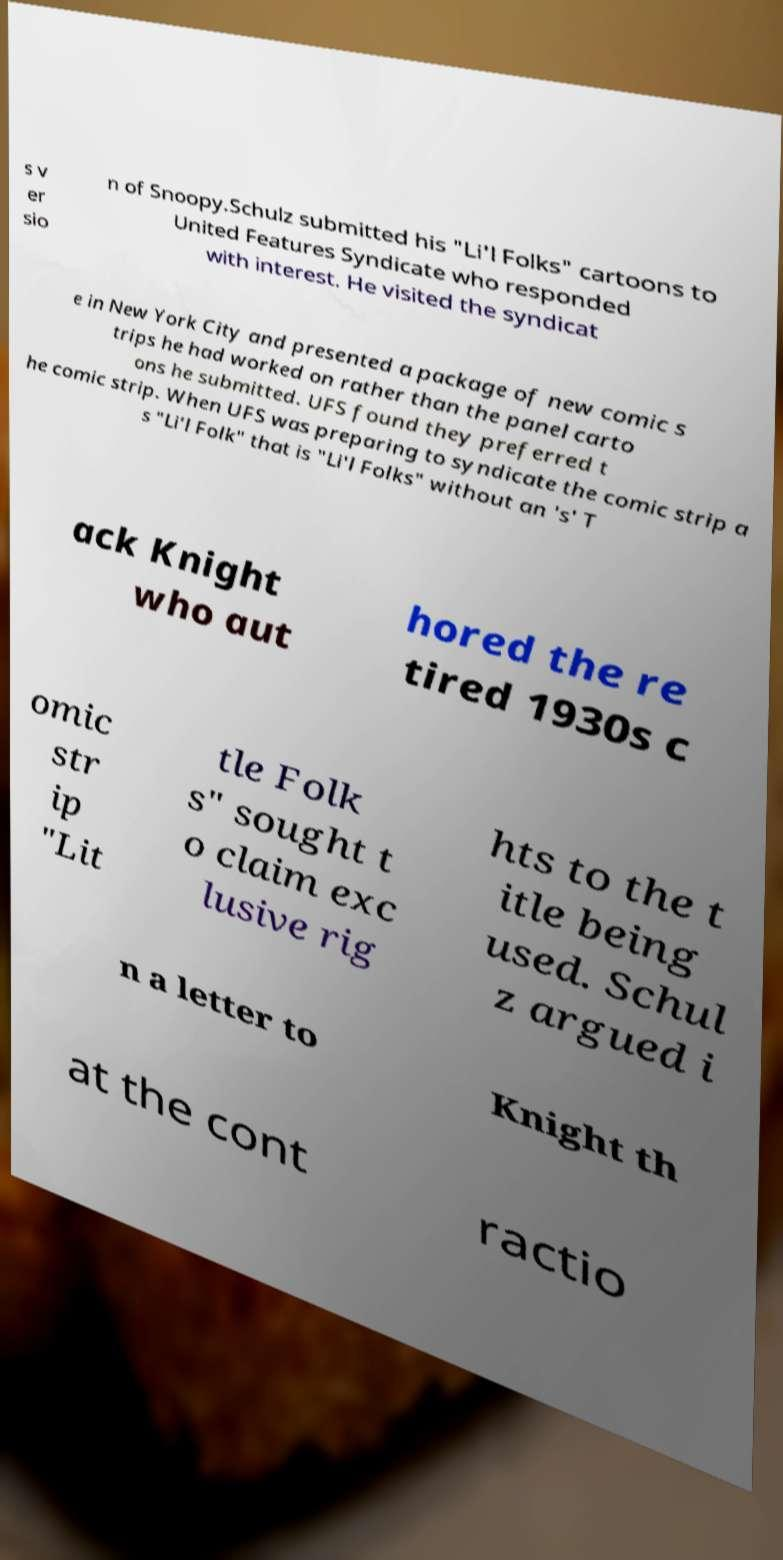For documentation purposes, I need the text within this image transcribed. Could you provide that? s v er sio n of Snoopy.Schulz submitted his "Li'l Folks" cartoons to United Features Syndicate who responded with interest. He visited the syndicat e in New York City and presented a package of new comic s trips he had worked on rather than the panel carto ons he submitted. UFS found they preferred t he comic strip. When UFS was preparing to syndicate the comic strip a s "Li'l Folk" that is "Li'l Folks" without an 's' T ack Knight who aut hored the re tired 1930s c omic str ip "Lit tle Folk s" sought t o claim exc lusive rig hts to the t itle being used. Schul z argued i n a letter to Knight th at the cont ractio 